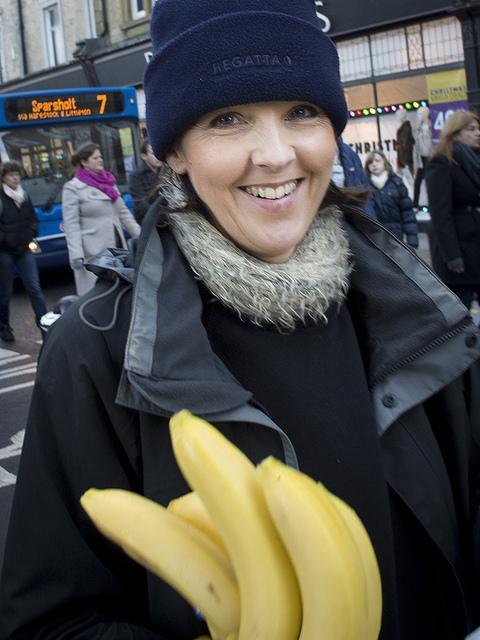How many bananas is she holding?
Give a very brief answer. 5. How many people are in the picture?
Give a very brief answer. 4. 